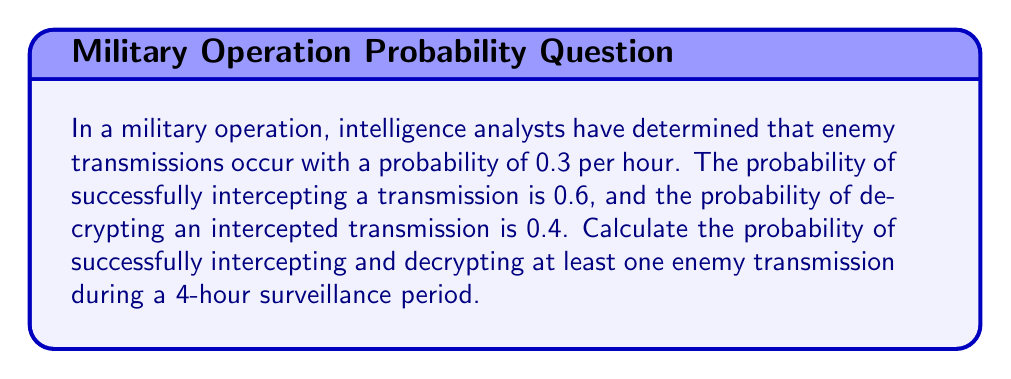Help me with this question. Let's approach this step-by-step:

1) First, we need to calculate the probability of successfully intercepting and decrypting a single transmission:
   $P(\text{intercept and decrypt}) = P(\text{intercept}) \times P(\text{decrypt}) = 0.6 \times 0.4 = 0.24$

2) Now, the probability of not intercepting and decrypting a transmission that occurs is:
   $1 - 0.24 = 0.76$

3) The probability of no transmission occurring in an hour is:
   $1 - 0.3 = 0.7$

4) So, the probability of not intercepting and decrypting a transmission in one hour is:
   $0.7 + (0.3 \times 0.76) = 0.928$

5) For a 4-hour period, the probability of not intercepting and decrypting any transmission is:
   $(0.928)^4 = 0.7421$

6) Therefore, the probability of intercepting and decrypting at least one transmission in 4 hours is:
   $1 - (0.928)^4 = 1 - 0.7421 = 0.2579$

7) We can express this as a percentage:
   $0.2579 \times 100\% = 25.79\%$
Answer: 25.79% 